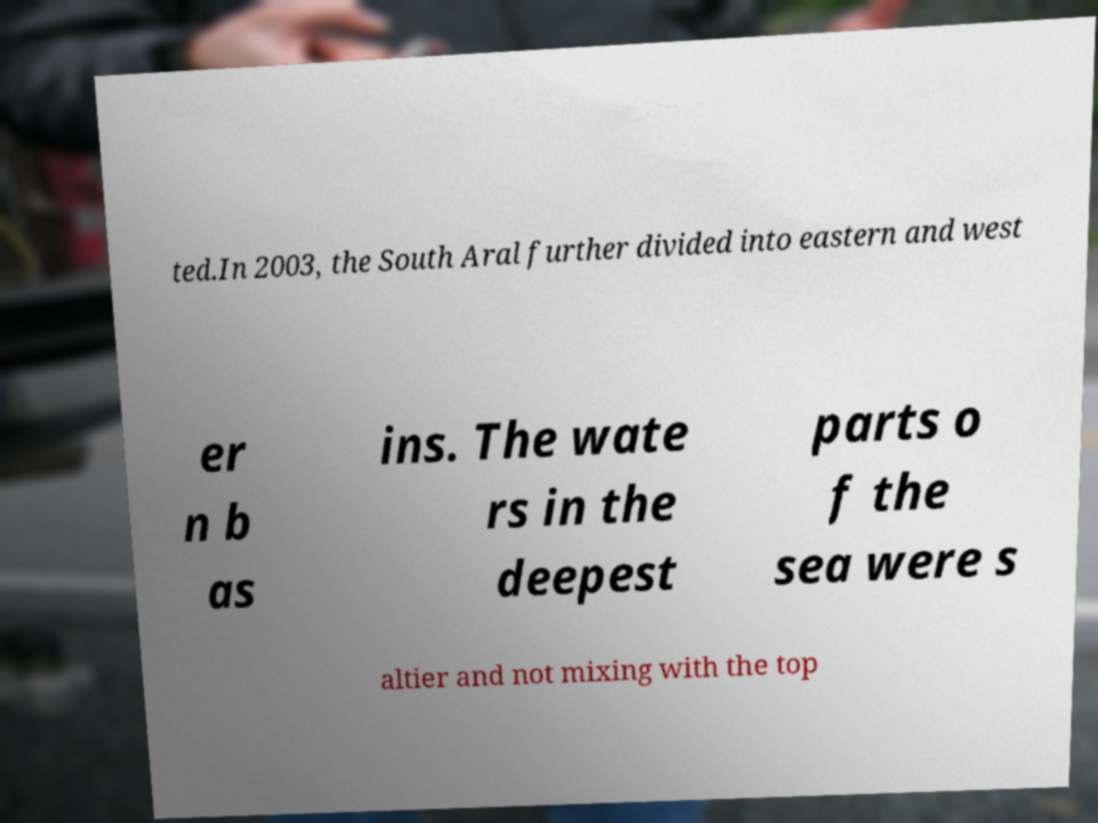Please read and relay the text visible in this image. What does it say? ted.In 2003, the South Aral further divided into eastern and west er n b as ins. The wate rs in the deepest parts o f the sea were s altier and not mixing with the top 